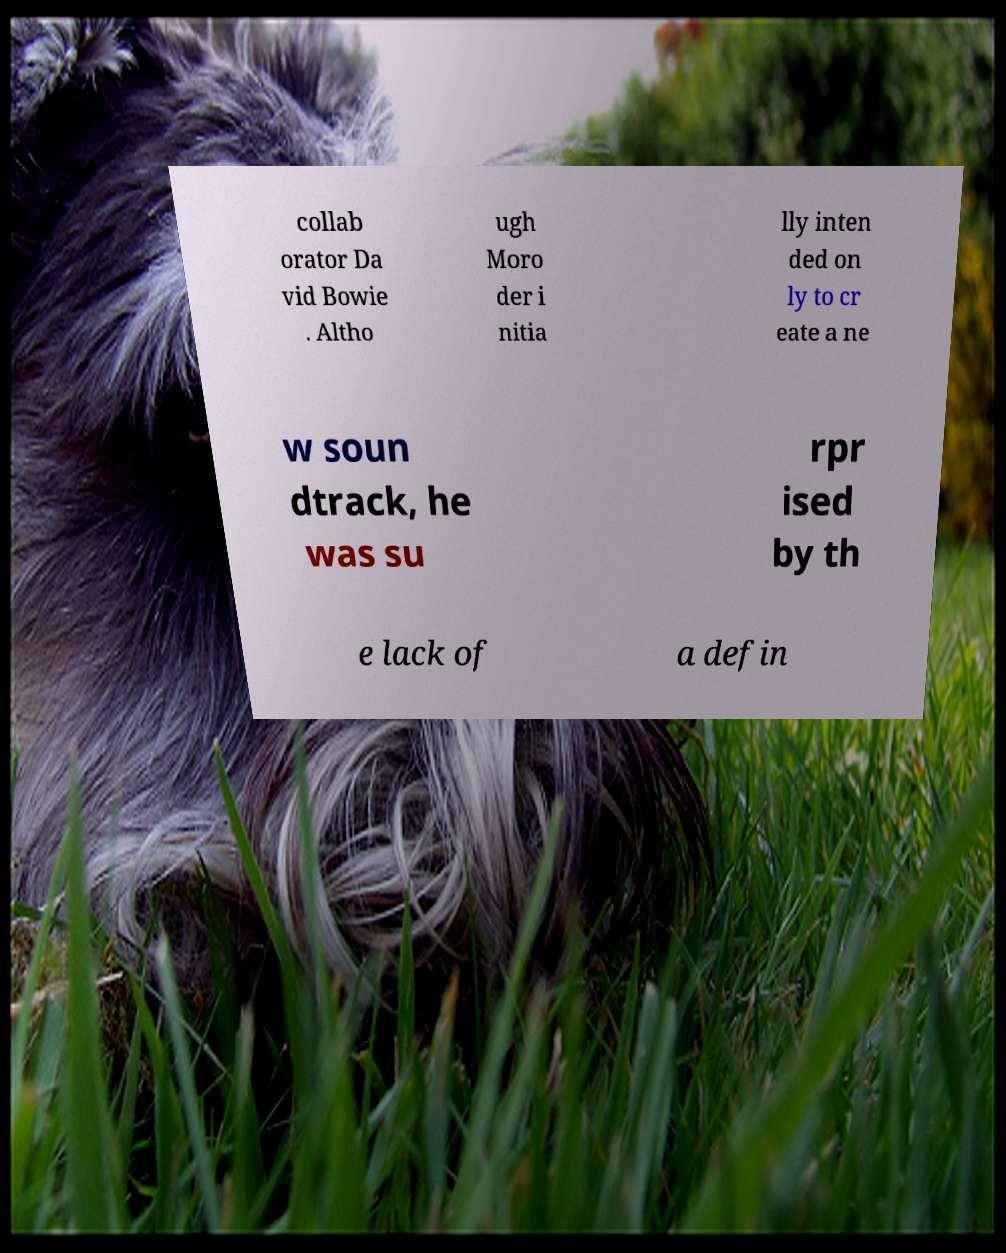What messages or text are displayed in this image? I need them in a readable, typed format. collab orator Da vid Bowie . Altho ugh Moro der i nitia lly inten ded on ly to cr eate a ne w soun dtrack, he was su rpr ised by th e lack of a defin 